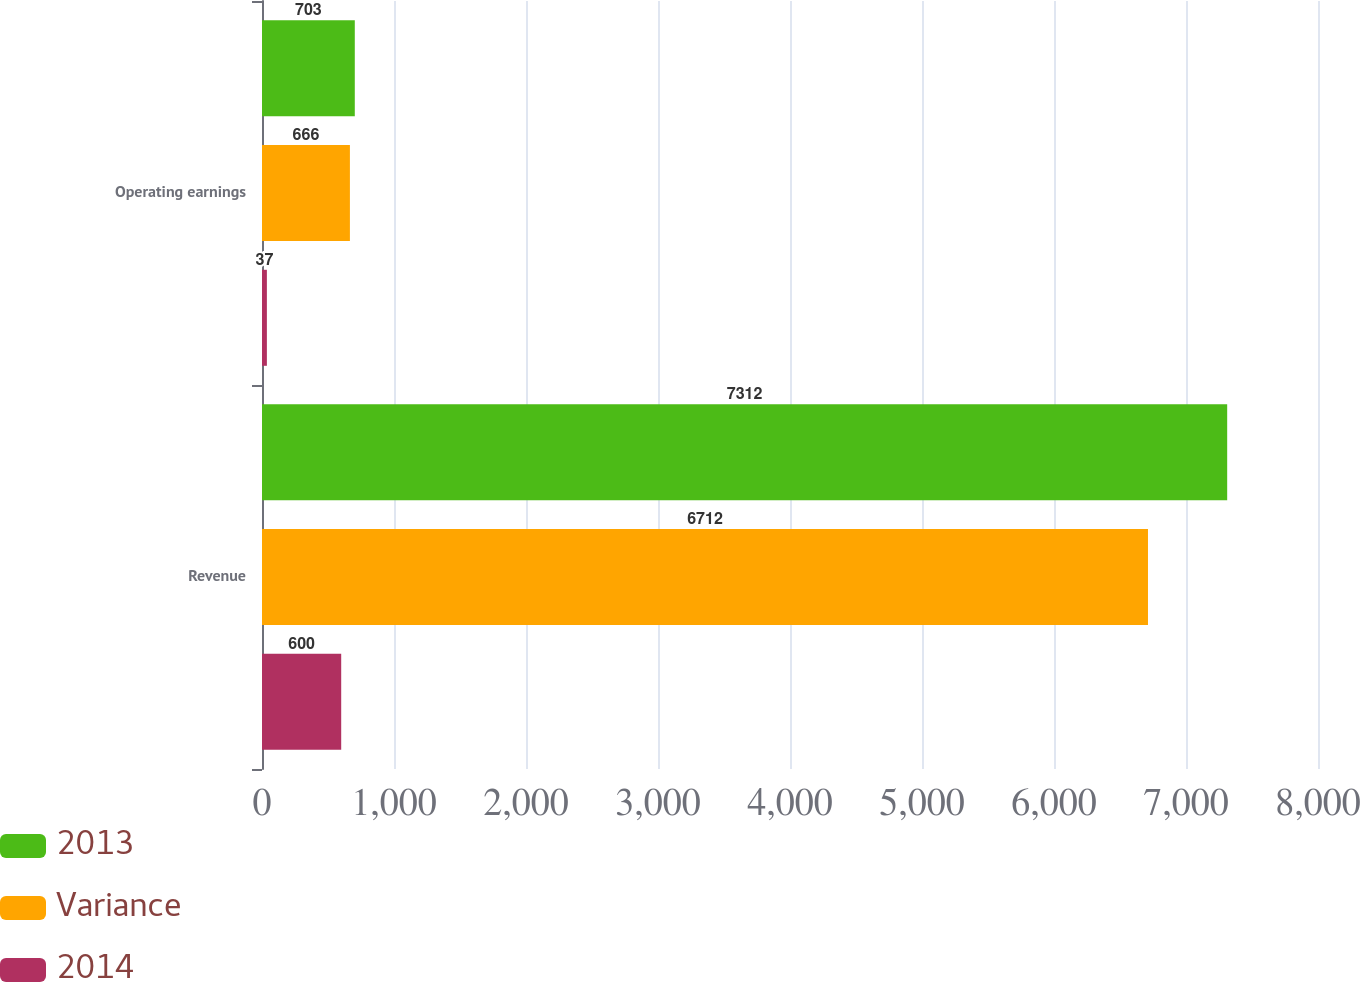Convert chart to OTSL. <chart><loc_0><loc_0><loc_500><loc_500><stacked_bar_chart><ecel><fcel>Revenue<fcel>Operating earnings<nl><fcel>2013<fcel>7312<fcel>703<nl><fcel>Variance<fcel>6712<fcel>666<nl><fcel>2014<fcel>600<fcel>37<nl></chart> 